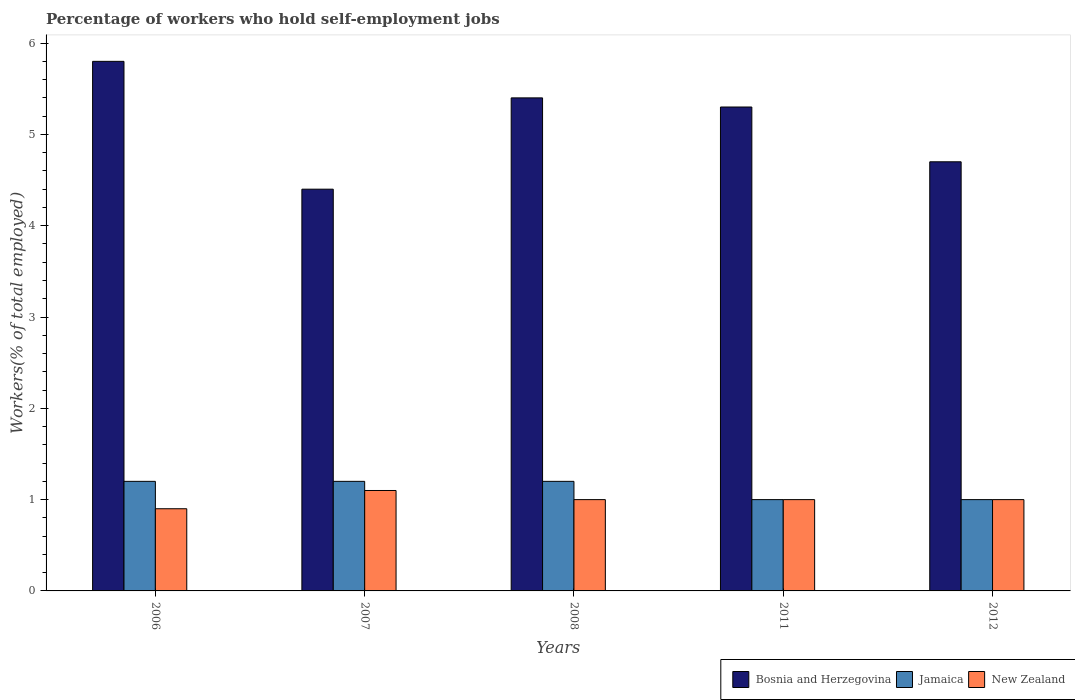How many different coloured bars are there?
Ensure brevity in your answer.  3. Are the number of bars per tick equal to the number of legend labels?
Ensure brevity in your answer.  Yes. Are the number of bars on each tick of the X-axis equal?
Your answer should be compact. Yes. How many bars are there on the 4th tick from the left?
Your response must be concise. 3. In how many cases, is the number of bars for a given year not equal to the number of legend labels?
Your answer should be very brief. 0. What is the percentage of self-employed workers in Bosnia and Herzegovina in 2008?
Offer a terse response. 5.4. Across all years, what is the maximum percentage of self-employed workers in Bosnia and Herzegovina?
Offer a terse response. 5.8. Across all years, what is the minimum percentage of self-employed workers in New Zealand?
Give a very brief answer. 0.9. In which year was the percentage of self-employed workers in Bosnia and Herzegovina maximum?
Offer a very short reply. 2006. In which year was the percentage of self-employed workers in Bosnia and Herzegovina minimum?
Make the answer very short. 2007. What is the total percentage of self-employed workers in Bosnia and Herzegovina in the graph?
Ensure brevity in your answer.  25.6. What is the difference between the percentage of self-employed workers in Jamaica in 2006 and that in 2007?
Make the answer very short. 0. What is the difference between the percentage of self-employed workers in Jamaica in 2007 and the percentage of self-employed workers in New Zealand in 2012?
Ensure brevity in your answer.  0.2. What is the average percentage of self-employed workers in Bosnia and Herzegovina per year?
Provide a short and direct response. 5.12. In the year 2011, what is the difference between the percentage of self-employed workers in Jamaica and percentage of self-employed workers in Bosnia and Herzegovina?
Keep it short and to the point. -4.3. In how many years, is the percentage of self-employed workers in New Zealand greater than 3.4 %?
Make the answer very short. 0. What is the ratio of the percentage of self-employed workers in Jamaica in 2007 to that in 2011?
Offer a terse response. 1.2. Is the difference between the percentage of self-employed workers in Jamaica in 2008 and 2012 greater than the difference between the percentage of self-employed workers in Bosnia and Herzegovina in 2008 and 2012?
Give a very brief answer. No. What is the difference between the highest and the second highest percentage of self-employed workers in New Zealand?
Your answer should be very brief. 0.1. What is the difference between the highest and the lowest percentage of self-employed workers in New Zealand?
Give a very brief answer. 0.2. In how many years, is the percentage of self-employed workers in Jamaica greater than the average percentage of self-employed workers in Jamaica taken over all years?
Offer a terse response. 3. Is the sum of the percentage of self-employed workers in Jamaica in 2007 and 2011 greater than the maximum percentage of self-employed workers in Bosnia and Herzegovina across all years?
Offer a very short reply. No. What does the 3rd bar from the left in 2012 represents?
Your answer should be compact. New Zealand. What does the 2nd bar from the right in 2007 represents?
Make the answer very short. Jamaica. Is it the case that in every year, the sum of the percentage of self-employed workers in Bosnia and Herzegovina and percentage of self-employed workers in New Zealand is greater than the percentage of self-employed workers in Jamaica?
Make the answer very short. Yes. How many bars are there?
Offer a very short reply. 15. Are all the bars in the graph horizontal?
Your answer should be very brief. No. Are the values on the major ticks of Y-axis written in scientific E-notation?
Make the answer very short. No. Does the graph contain grids?
Make the answer very short. No. Where does the legend appear in the graph?
Keep it short and to the point. Bottom right. How many legend labels are there?
Ensure brevity in your answer.  3. How are the legend labels stacked?
Provide a succinct answer. Horizontal. What is the title of the graph?
Make the answer very short. Percentage of workers who hold self-employment jobs. What is the label or title of the X-axis?
Ensure brevity in your answer.  Years. What is the label or title of the Y-axis?
Ensure brevity in your answer.  Workers(% of total employed). What is the Workers(% of total employed) in Bosnia and Herzegovina in 2006?
Your response must be concise. 5.8. What is the Workers(% of total employed) in Jamaica in 2006?
Provide a succinct answer. 1.2. What is the Workers(% of total employed) in New Zealand in 2006?
Offer a very short reply. 0.9. What is the Workers(% of total employed) of Bosnia and Herzegovina in 2007?
Offer a terse response. 4.4. What is the Workers(% of total employed) of Jamaica in 2007?
Provide a short and direct response. 1.2. What is the Workers(% of total employed) of New Zealand in 2007?
Your answer should be very brief. 1.1. What is the Workers(% of total employed) in Bosnia and Herzegovina in 2008?
Give a very brief answer. 5.4. What is the Workers(% of total employed) in Jamaica in 2008?
Ensure brevity in your answer.  1.2. What is the Workers(% of total employed) in Bosnia and Herzegovina in 2011?
Provide a succinct answer. 5.3. What is the Workers(% of total employed) in Bosnia and Herzegovina in 2012?
Give a very brief answer. 4.7. What is the Workers(% of total employed) of Jamaica in 2012?
Ensure brevity in your answer.  1. What is the Workers(% of total employed) in New Zealand in 2012?
Give a very brief answer. 1. Across all years, what is the maximum Workers(% of total employed) in Bosnia and Herzegovina?
Your answer should be compact. 5.8. Across all years, what is the maximum Workers(% of total employed) of Jamaica?
Offer a very short reply. 1.2. Across all years, what is the maximum Workers(% of total employed) of New Zealand?
Make the answer very short. 1.1. Across all years, what is the minimum Workers(% of total employed) in Bosnia and Herzegovina?
Offer a terse response. 4.4. Across all years, what is the minimum Workers(% of total employed) in New Zealand?
Offer a terse response. 0.9. What is the total Workers(% of total employed) in Bosnia and Herzegovina in the graph?
Give a very brief answer. 25.6. What is the total Workers(% of total employed) of Jamaica in the graph?
Give a very brief answer. 5.6. What is the total Workers(% of total employed) of New Zealand in the graph?
Offer a very short reply. 5. What is the difference between the Workers(% of total employed) in Bosnia and Herzegovina in 2006 and that in 2007?
Provide a short and direct response. 1.4. What is the difference between the Workers(% of total employed) of Jamaica in 2006 and that in 2007?
Keep it short and to the point. 0. What is the difference between the Workers(% of total employed) in New Zealand in 2006 and that in 2007?
Your answer should be compact. -0.2. What is the difference between the Workers(% of total employed) of Bosnia and Herzegovina in 2006 and that in 2008?
Your answer should be very brief. 0.4. What is the difference between the Workers(% of total employed) in Bosnia and Herzegovina in 2006 and that in 2011?
Give a very brief answer. 0.5. What is the difference between the Workers(% of total employed) in Bosnia and Herzegovina in 2006 and that in 2012?
Make the answer very short. 1.1. What is the difference between the Workers(% of total employed) in New Zealand in 2006 and that in 2012?
Offer a very short reply. -0.1. What is the difference between the Workers(% of total employed) of Jamaica in 2007 and that in 2008?
Keep it short and to the point. 0. What is the difference between the Workers(% of total employed) in New Zealand in 2007 and that in 2008?
Your response must be concise. 0.1. What is the difference between the Workers(% of total employed) of Bosnia and Herzegovina in 2007 and that in 2011?
Give a very brief answer. -0.9. What is the difference between the Workers(% of total employed) of Bosnia and Herzegovina in 2007 and that in 2012?
Your answer should be compact. -0.3. What is the difference between the Workers(% of total employed) in Bosnia and Herzegovina in 2008 and that in 2011?
Make the answer very short. 0.1. What is the difference between the Workers(% of total employed) in Jamaica in 2008 and that in 2011?
Provide a succinct answer. 0.2. What is the difference between the Workers(% of total employed) of Bosnia and Herzegovina in 2008 and that in 2012?
Offer a very short reply. 0.7. What is the difference between the Workers(% of total employed) of Jamaica in 2008 and that in 2012?
Your response must be concise. 0.2. What is the difference between the Workers(% of total employed) of Bosnia and Herzegovina in 2011 and that in 2012?
Offer a terse response. 0.6. What is the difference between the Workers(% of total employed) of Bosnia and Herzegovina in 2006 and the Workers(% of total employed) of Jamaica in 2011?
Ensure brevity in your answer.  4.8. What is the difference between the Workers(% of total employed) of Bosnia and Herzegovina in 2006 and the Workers(% of total employed) of New Zealand in 2011?
Make the answer very short. 4.8. What is the difference between the Workers(% of total employed) of Bosnia and Herzegovina in 2006 and the Workers(% of total employed) of Jamaica in 2012?
Offer a very short reply. 4.8. What is the difference between the Workers(% of total employed) in Bosnia and Herzegovina in 2006 and the Workers(% of total employed) in New Zealand in 2012?
Provide a short and direct response. 4.8. What is the difference between the Workers(% of total employed) in Jamaica in 2006 and the Workers(% of total employed) in New Zealand in 2012?
Your answer should be very brief. 0.2. What is the difference between the Workers(% of total employed) of Bosnia and Herzegovina in 2007 and the Workers(% of total employed) of New Zealand in 2012?
Your response must be concise. 3.4. What is the difference between the Workers(% of total employed) of Bosnia and Herzegovina in 2008 and the Workers(% of total employed) of Jamaica in 2011?
Your answer should be very brief. 4.4. What is the difference between the Workers(% of total employed) in Bosnia and Herzegovina in 2008 and the Workers(% of total employed) in Jamaica in 2012?
Your answer should be very brief. 4.4. What is the difference between the Workers(% of total employed) of Bosnia and Herzegovina in 2008 and the Workers(% of total employed) of New Zealand in 2012?
Your answer should be compact. 4.4. What is the difference between the Workers(% of total employed) in Jamaica in 2011 and the Workers(% of total employed) in New Zealand in 2012?
Keep it short and to the point. 0. What is the average Workers(% of total employed) of Bosnia and Herzegovina per year?
Your answer should be compact. 5.12. What is the average Workers(% of total employed) in Jamaica per year?
Your answer should be compact. 1.12. In the year 2006, what is the difference between the Workers(% of total employed) of Jamaica and Workers(% of total employed) of New Zealand?
Give a very brief answer. 0.3. In the year 2008, what is the difference between the Workers(% of total employed) of Bosnia and Herzegovina and Workers(% of total employed) of Jamaica?
Your response must be concise. 4.2. In the year 2011, what is the difference between the Workers(% of total employed) in Bosnia and Herzegovina and Workers(% of total employed) in New Zealand?
Keep it short and to the point. 4.3. In the year 2011, what is the difference between the Workers(% of total employed) of Jamaica and Workers(% of total employed) of New Zealand?
Your response must be concise. 0. What is the ratio of the Workers(% of total employed) of Bosnia and Herzegovina in 2006 to that in 2007?
Make the answer very short. 1.32. What is the ratio of the Workers(% of total employed) of Jamaica in 2006 to that in 2007?
Provide a succinct answer. 1. What is the ratio of the Workers(% of total employed) of New Zealand in 2006 to that in 2007?
Provide a succinct answer. 0.82. What is the ratio of the Workers(% of total employed) of Bosnia and Herzegovina in 2006 to that in 2008?
Your answer should be very brief. 1.07. What is the ratio of the Workers(% of total employed) of Jamaica in 2006 to that in 2008?
Give a very brief answer. 1. What is the ratio of the Workers(% of total employed) of Bosnia and Herzegovina in 2006 to that in 2011?
Your response must be concise. 1.09. What is the ratio of the Workers(% of total employed) in Bosnia and Herzegovina in 2006 to that in 2012?
Ensure brevity in your answer.  1.23. What is the ratio of the Workers(% of total employed) of Bosnia and Herzegovina in 2007 to that in 2008?
Your answer should be very brief. 0.81. What is the ratio of the Workers(% of total employed) in Bosnia and Herzegovina in 2007 to that in 2011?
Your response must be concise. 0.83. What is the ratio of the Workers(% of total employed) of New Zealand in 2007 to that in 2011?
Your answer should be very brief. 1.1. What is the ratio of the Workers(% of total employed) in Bosnia and Herzegovina in 2007 to that in 2012?
Provide a succinct answer. 0.94. What is the ratio of the Workers(% of total employed) of Jamaica in 2007 to that in 2012?
Your answer should be compact. 1.2. What is the ratio of the Workers(% of total employed) of New Zealand in 2007 to that in 2012?
Offer a terse response. 1.1. What is the ratio of the Workers(% of total employed) in Bosnia and Herzegovina in 2008 to that in 2011?
Give a very brief answer. 1.02. What is the ratio of the Workers(% of total employed) of Jamaica in 2008 to that in 2011?
Your response must be concise. 1.2. What is the ratio of the Workers(% of total employed) in New Zealand in 2008 to that in 2011?
Offer a very short reply. 1. What is the ratio of the Workers(% of total employed) in Bosnia and Herzegovina in 2008 to that in 2012?
Provide a succinct answer. 1.15. What is the ratio of the Workers(% of total employed) in Bosnia and Herzegovina in 2011 to that in 2012?
Provide a short and direct response. 1.13. What is the ratio of the Workers(% of total employed) in New Zealand in 2011 to that in 2012?
Offer a very short reply. 1. What is the difference between the highest and the second highest Workers(% of total employed) of Bosnia and Herzegovina?
Offer a very short reply. 0.4. What is the difference between the highest and the second highest Workers(% of total employed) of New Zealand?
Your answer should be very brief. 0.1. What is the difference between the highest and the lowest Workers(% of total employed) of Jamaica?
Offer a very short reply. 0.2. What is the difference between the highest and the lowest Workers(% of total employed) in New Zealand?
Make the answer very short. 0.2. 